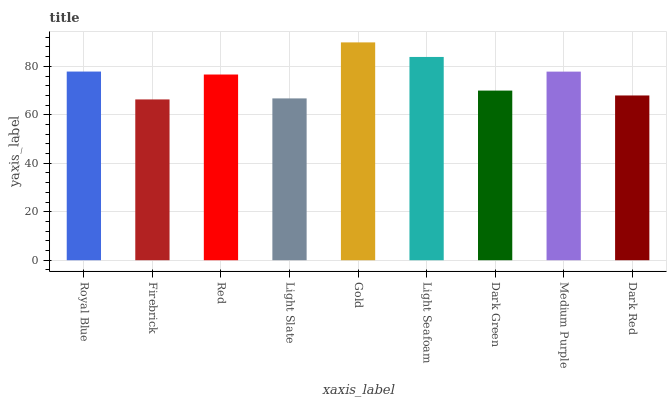Is Firebrick the minimum?
Answer yes or no. Yes. Is Gold the maximum?
Answer yes or no. Yes. Is Red the minimum?
Answer yes or no. No. Is Red the maximum?
Answer yes or no. No. Is Red greater than Firebrick?
Answer yes or no. Yes. Is Firebrick less than Red?
Answer yes or no. Yes. Is Firebrick greater than Red?
Answer yes or no. No. Is Red less than Firebrick?
Answer yes or no. No. Is Red the high median?
Answer yes or no. Yes. Is Red the low median?
Answer yes or no. Yes. Is Light Seafoam the high median?
Answer yes or no. No. Is Royal Blue the low median?
Answer yes or no. No. 